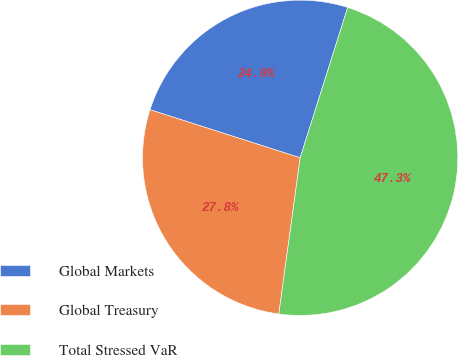Convert chart. <chart><loc_0><loc_0><loc_500><loc_500><pie_chart><fcel>Global Markets<fcel>Global Treasury<fcel>Total Stressed VaR<nl><fcel>24.94%<fcel>27.77%<fcel>47.28%<nl></chart> 